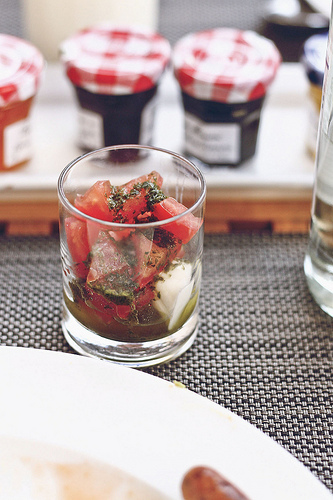<image>
Can you confirm if the jam is behind the plate? Yes. From this viewpoint, the jam is positioned behind the plate, with the plate partially or fully occluding the jam. Is the glass next to the jam jar? Yes. The glass is positioned adjacent to the jam jar, located nearby in the same general area. 